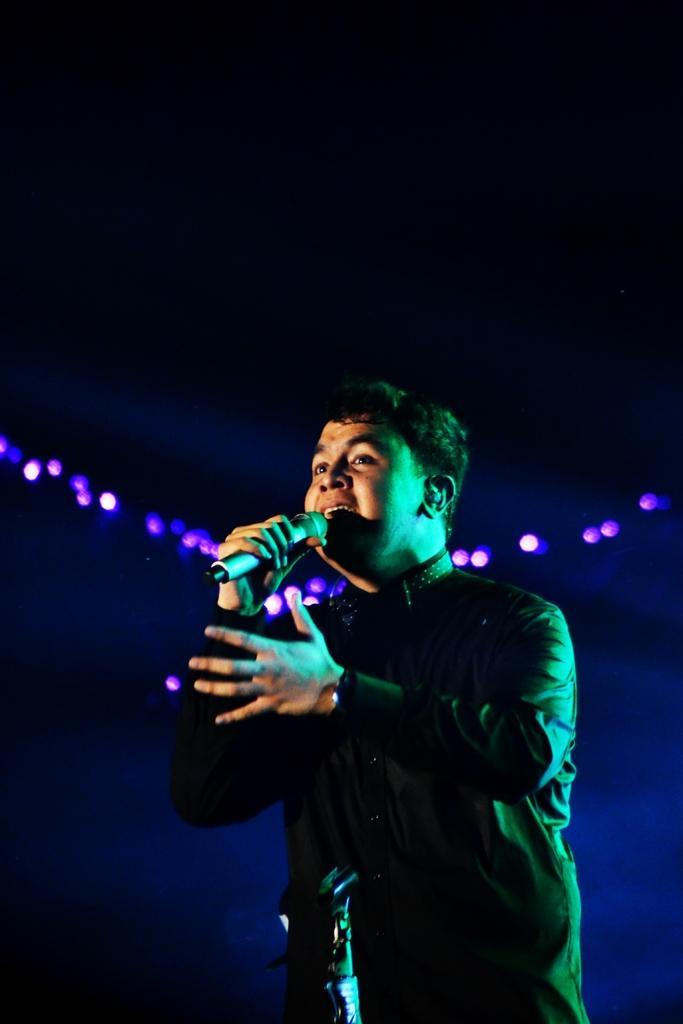In one or two sentences, can you explain what this image depicts? In this image, we can see a person is holding a microphone and singing. At the bottom, we can see an object. Background there is a dark view. Here we can see the lights. 